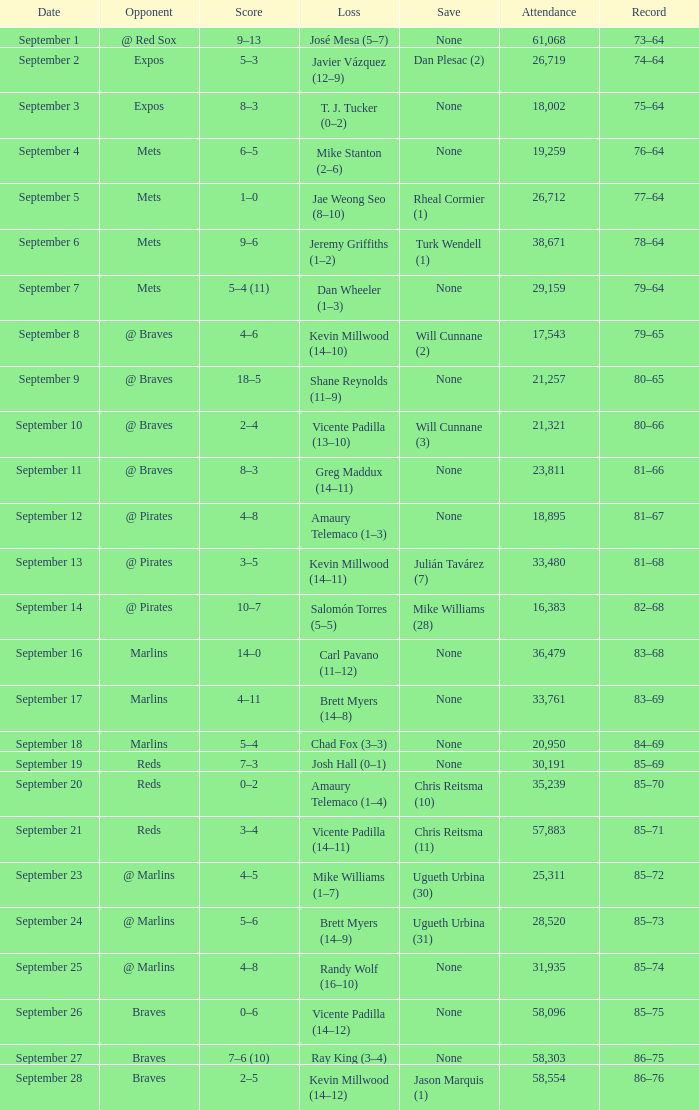What was the result of the contest in which chad fox experienced a loss (3-3)? 5–4. 